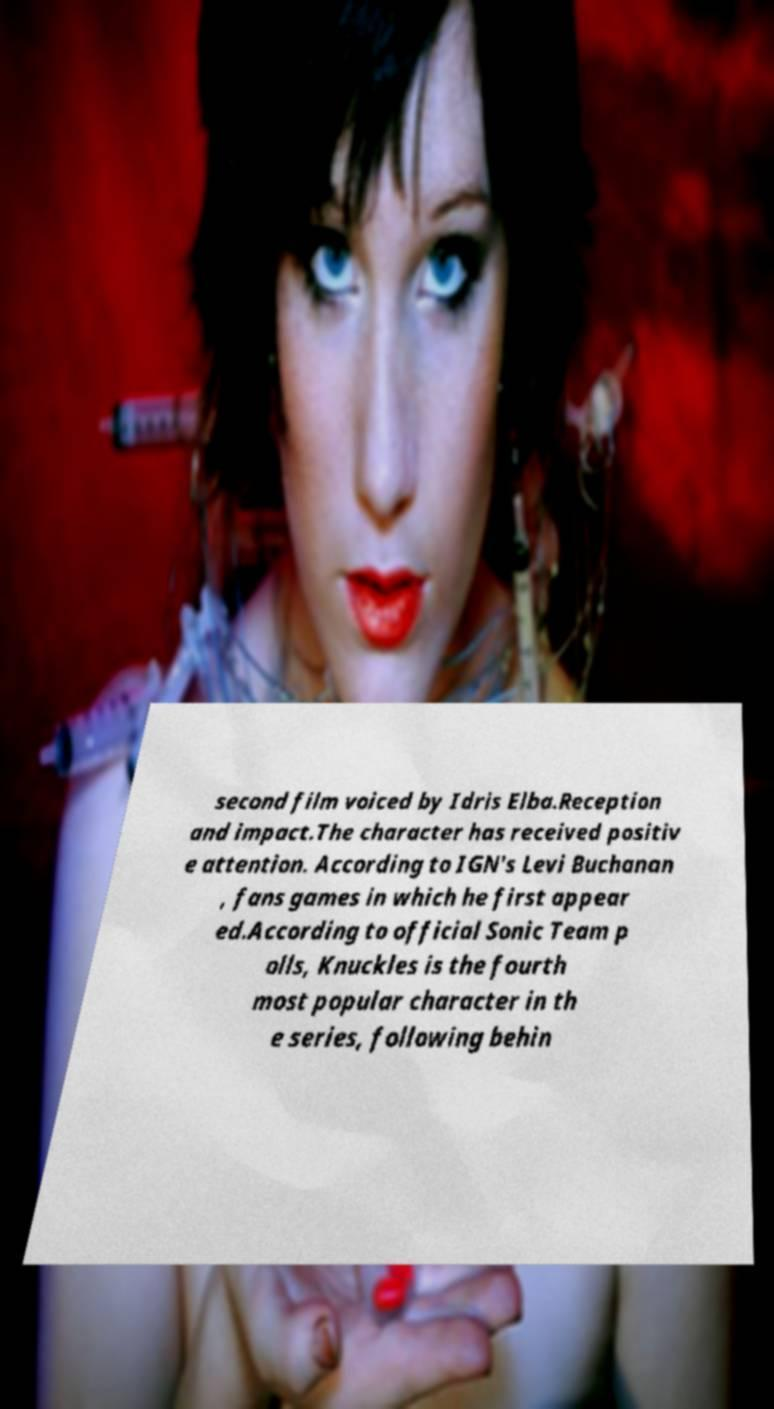Can you accurately transcribe the text from the provided image for me? second film voiced by Idris Elba.Reception and impact.The character has received positiv e attention. According to IGN's Levi Buchanan , fans games in which he first appear ed.According to official Sonic Team p olls, Knuckles is the fourth most popular character in th e series, following behin 